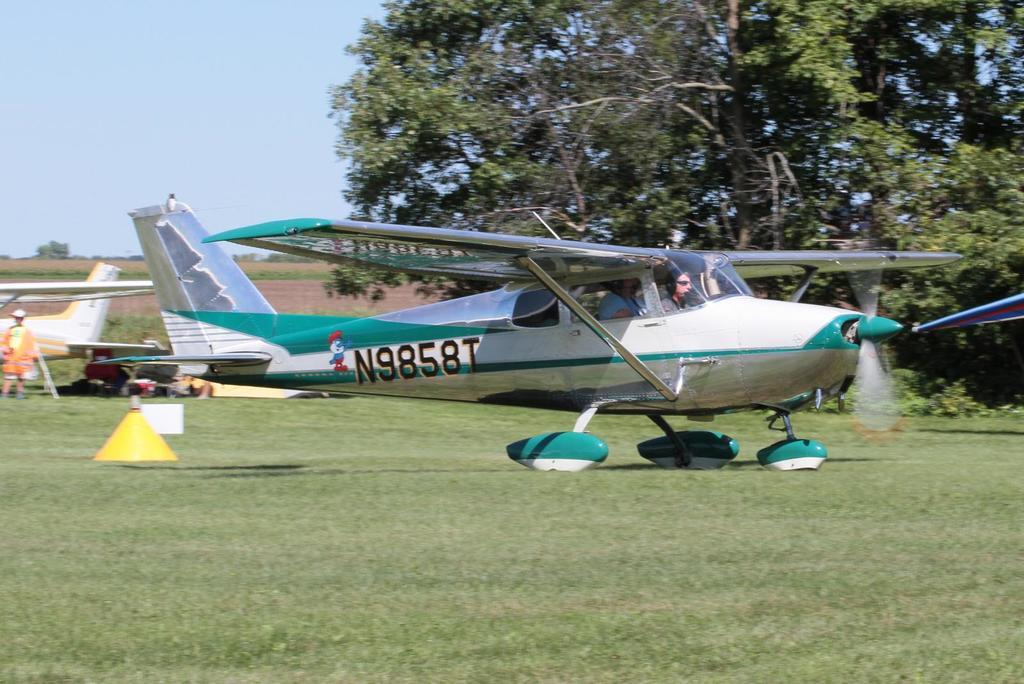<image>
Describe the image concisely. A light colored small prop plane has the number N9858T on its body. 